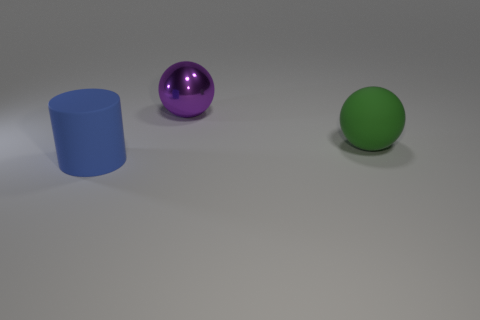There is a thing left of the purple sphere; what number of rubber things are behind it?
Provide a short and direct response. 1. There is a matte cylinder; is its color the same as the ball to the left of the big green matte thing?
Your answer should be compact. No. There is a shiny object that is the same size as the blue matte thing; what is its color?
Offer a terse response. Purple. Are there any big purple metallic things of the same shape as the green object?
Offer a terse response. Yes. Are there fewer big matte balls than big matte objects?
Offer a very short reply. Yes. There is a large ball to the left of the big green matte object; what color is it?
Your response must be concise. Purple. The object that is behind the big rubber thing behind the blue object is what shape?
Provide a short and direct response. Sphere. Are the large blue cylinder and the large thing that is behind the large green sphere made of the same material?
Ensure brevity in your answer.  No. What number of other purple things have the same size as the metal object?
Provide a short and direct response. 0. Is the number of purple spheres in front of the purple ball less than the number of large brown balls?
Offer a terse response. No. 